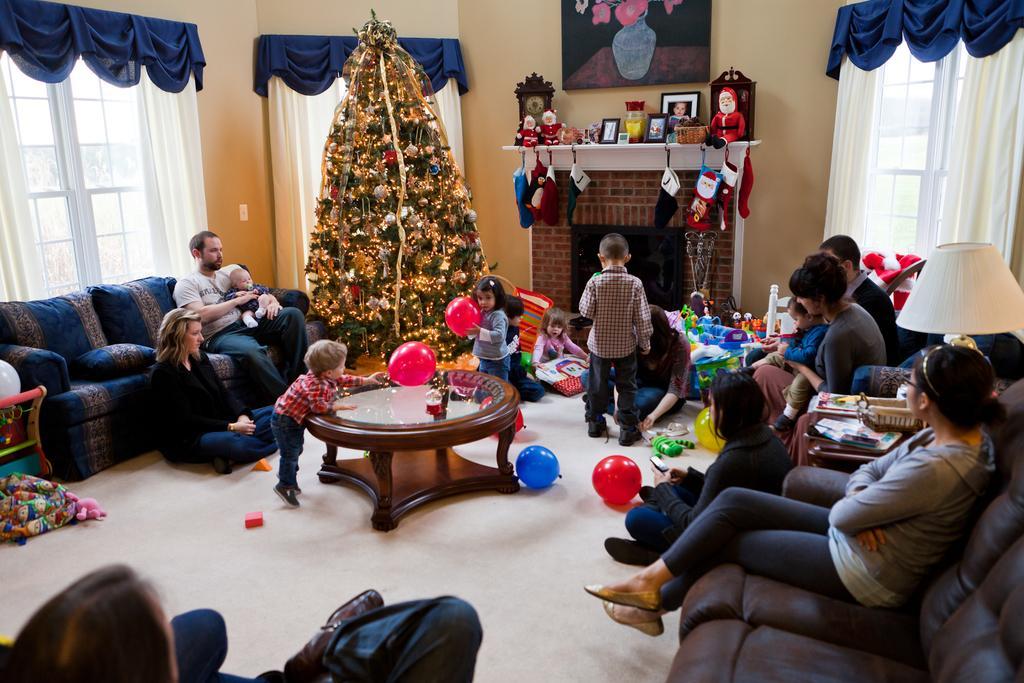How would you summarize this image in a sentence or two? In this picture there are group of people who are sitting on the chair. There is a woman sitting on the ground. There is a girl and a boy holding a balloon. There are few objects on the background. There is a toy, frame and a clock on the desk. There is a frame on the wall. There is a curtain. There is a christmas tree and lamp. 